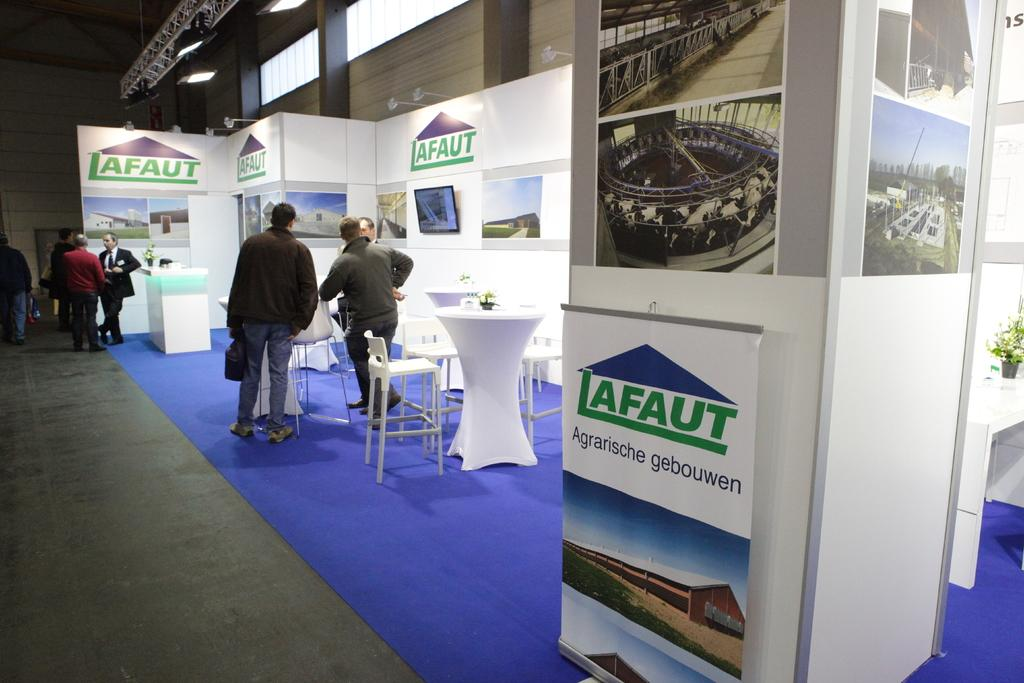<image>
Give a short and clear explanation of the subsequent image. A Lafaut booth at a convention has white furniture and a bright blue carpet. 